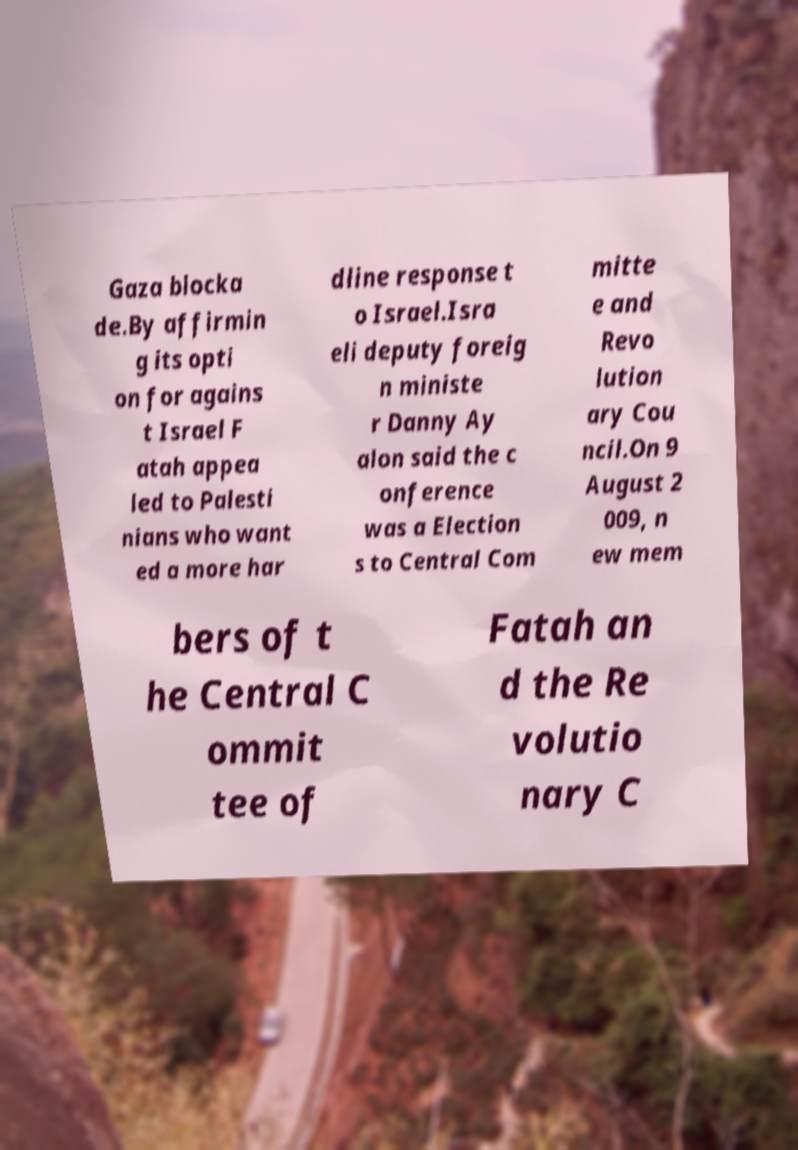What messages or text are displayed in this image? I need them in a readable, typed format. Gaza blocka de.By affirmin g its opti on for agains t Israel F atah appea led to Palesti nians who want ed a more har dline response t o Israel.Isra eli deputy foreig n ministe r Danny Ay alon said the c onference was a Election s to Central Com mitte e and Revo lution ary Cou ncil.On 9 August 2 009, n ew mem bers of t he Central C ommit tee of Fatah an d the Re volutio nary C 